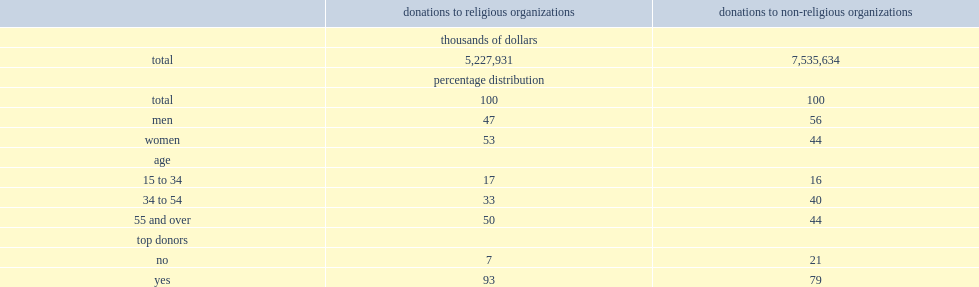Which gender was more likely to make a donation contributed of the total donations made to religious organizations? Women. What was the percentage of all donations to non-religious organizations made by men? 56.0. What was the percentage of all donations made to religious organizations by persons aged 55 and over in 2013? 50.0. What was the percentage of all donations made to non-religious organizations by persons aged 55 and over? 44.0. What the percentage of all donations to religious organizations in 2013? 93.0. What the percentage of all donations to non-religious organizations in 2013? 79.0. 